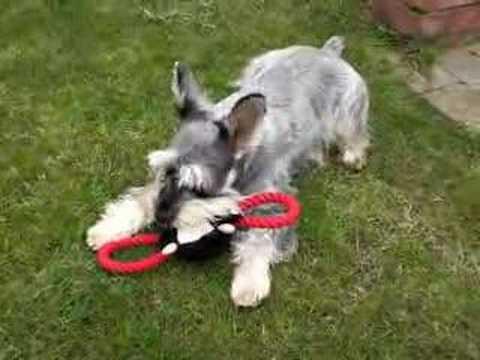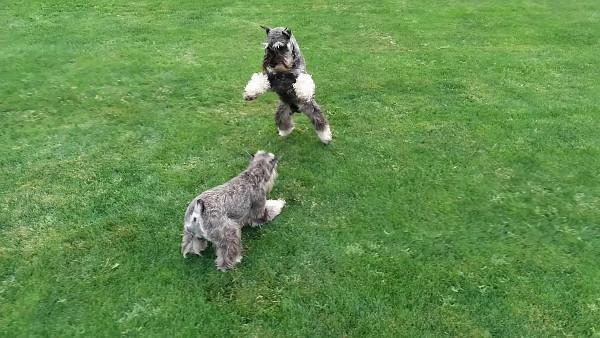The first image is the image on the left, the second image is the image on the right. For the images displayed, is the sentence "In one of the images there is a single dog that is holding something in its mouth and in the other there are two dogs playing." factually correct? Answer yes or no. Yes. 